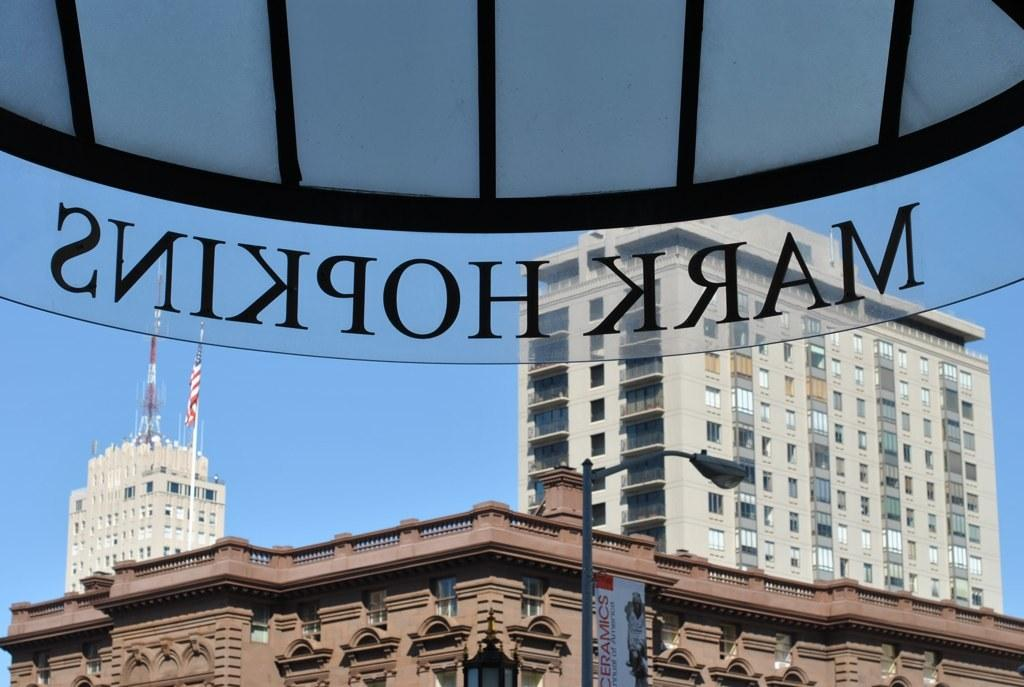What type of structures can be seen in the image? There are buildings in the image. What is another object visible in the image? There is a lamp post in the image. Are there any features on top of the buildings? Yes, there are flag posts on top of the buildings. What can be seen at the top of the image? There is a rooftop with a name on it at the top of the image. What type of jeans is the ball wearing on its head in the image? There is no ball or jeans present in the image; it features buildings, a lamp post, flag posts, and a rooftop with a name. 